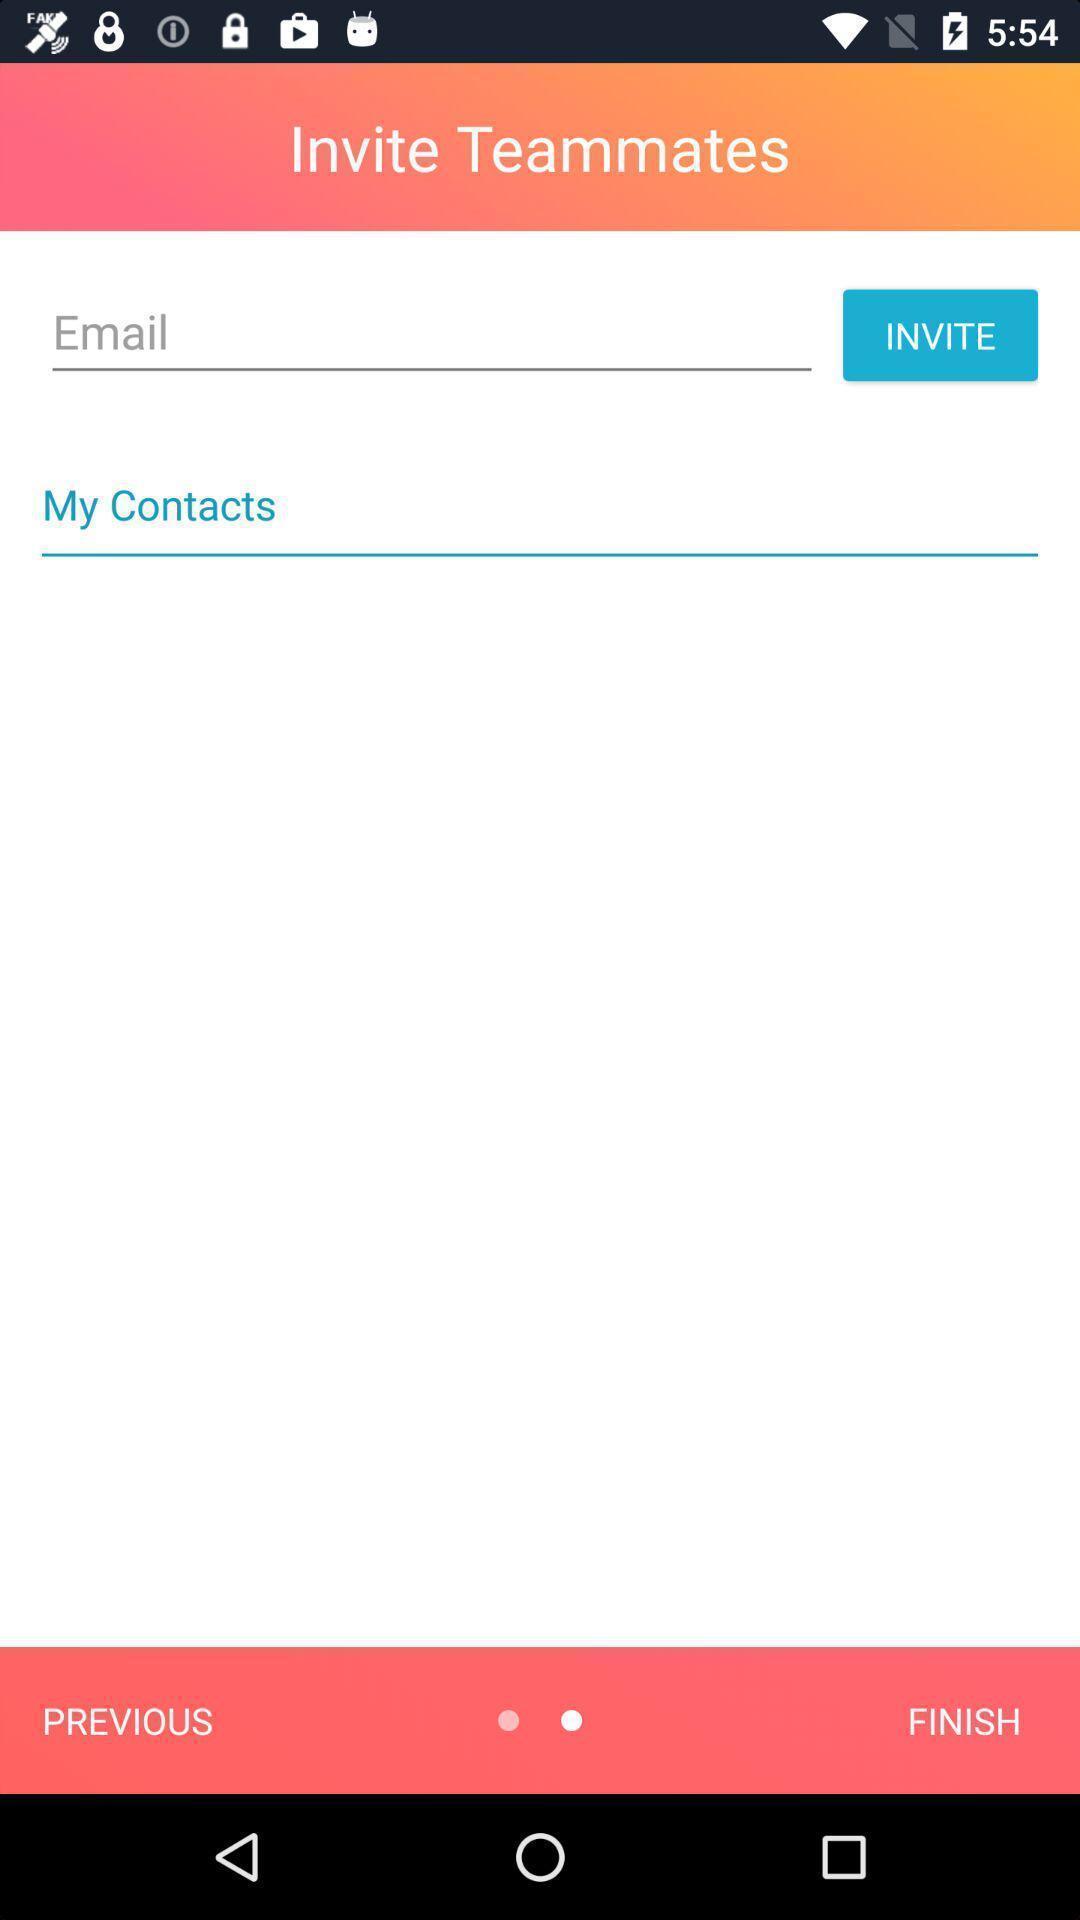What details can you identify in this image? Welcome page. 